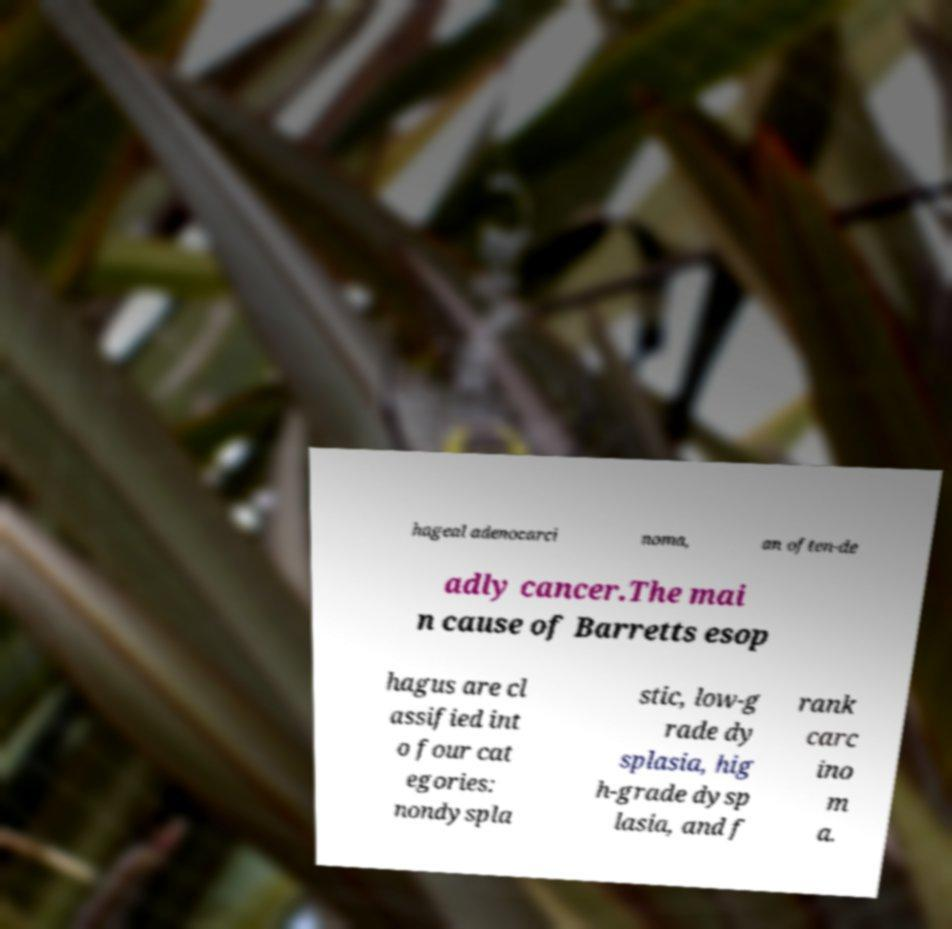There's text embedded in this image that I need extracted. Can you transcribe it verbatim? hageal adenocarci noma, an often-de adly cancer.The mai n cause of Barretts esop hagus are cl assified int o four cat egories: nondyspla stic, low-g rade dy splasia, hig h-grade dysp lasia, and f rank carc ino m a. 